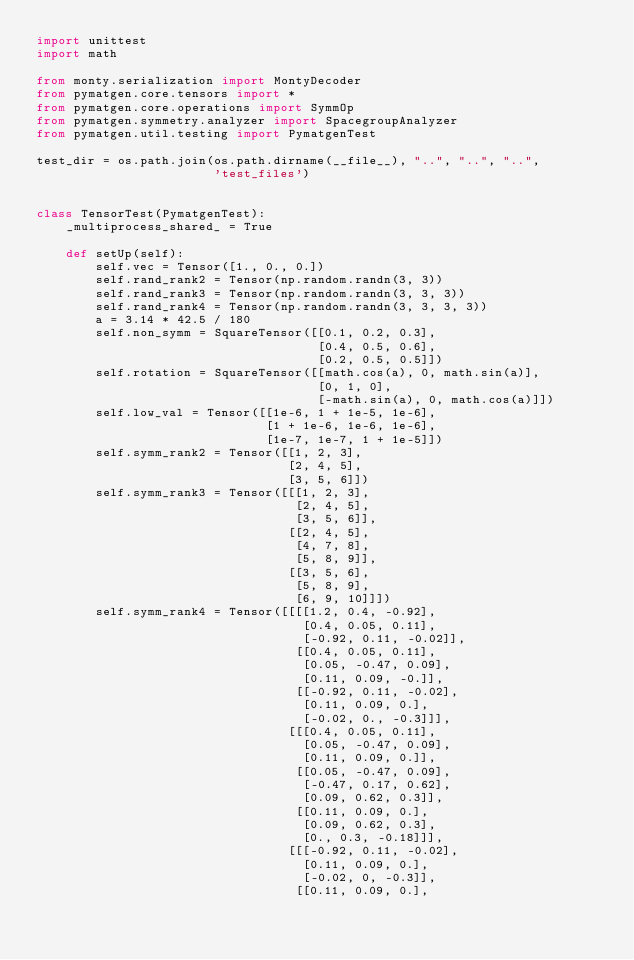Convert code to text. <code><loc_0><loc_0><loc_500><loc_500><_Python_>import unittest
import math

from monty.serialization import MontyDecoder
from pymatgen.core.tensors import *
from pymatgen.core.operations import SymmOp
from pymatgen.symmetry.analyzer import SpacegroupAnalyzer
from pymatgen.util.testing import PymatgenTest

test_dir = os.path.join(os.path.dirname(__file__), "..", "..", "..",
                        'test_files')


class TensorTest(PymatgenTest):
    _multiprocess_shared_ = True

    def setUp(self):
        self.vec = Tensor([1., 0., 0.])
        self.rand_rank2 = Tensor(np.random.randn(3, 3))
        self.rand_rank3 = Tensor(np.random.randn(3, 3, 3))
        self.rand_rank4 = Tensor(np.random.randn(3, 3, 3, 3))
        a = 3.14 * 42.5 / 180
        self.non_symm = SquareTensor([[0.1, 0.2, 0.3],
                                      [0.4, 0.5, 0.6],
                                      [0.2, 0.5, 0.5]])
        self.rotation = SquareTensor([[math.cos(a), 0, math.sin(a)],
                                      [0, 1, 0],
                                      [-math.sin(a), 0, math.cos(a)]])
        self.low_val = Tensor([[1e-6, 1 + 1e-5, 1e-6],
                               [1 + 1e-6, 1e-6, 1e-6],
                               [1e-7, 1e-7, 1 + 1e-5]])
        self.symm_rank2 = Tensor([[1, 2, 3],
                                  [2, 4, 5],
                                  [3, 5, 6]])
        self.symm_rank3 = Tensor([[[1, 2, 3],
                                   [2, 4, 5],
                                   [3, 5, 6]],
                                  [[2, 4, 5],
                                   [4, 7, 8],
                                   [5, 8, 9]],
                                  [[3, 5, 6],
                                   [5, 8, 9],
                                   [6, 9, 10]]])
        self.symm_rank4 = Tensor([[[[1.2, 0.4, -0.92],
                                    [0.4, 0.05, 0.11],
                                    [-0.92, 0.11, -0.02]],
                                   [[0.4, 0.05, 0.11],
                                    [0.05, -0.47, 0.09],
                                    [0.11, 0.09, -0.]],
                                   [[-0.92, 0.11, -0.02],
                                    [0.11, 0.09, 0.],
                                    [-0.02, 0., -0.3]]],
                                  [[[0.4, 0.05, 0.11],
                                    [0.05, -0.47, 0.09],
                                    [0.11, 0.09, 0.]],
                                   [[0.05, -0.47, 0.09],
                                    [-0.47, 0.17, 0.62],
                                    [0.09, 0.62, 0.3]],
                                   [[0.11, 0.09, 0.],
                                    [0.09, 0.62, 0.3],
                                    [0., 0.3, -0.18]]],
                                  [[[-0.92, 0.11, -0.02],
                                    [0.11, 0.09, 0.],
                                    [-0.02, 0, -0.3]],
                                   [[0.11, 0.09, 0.],</code> 